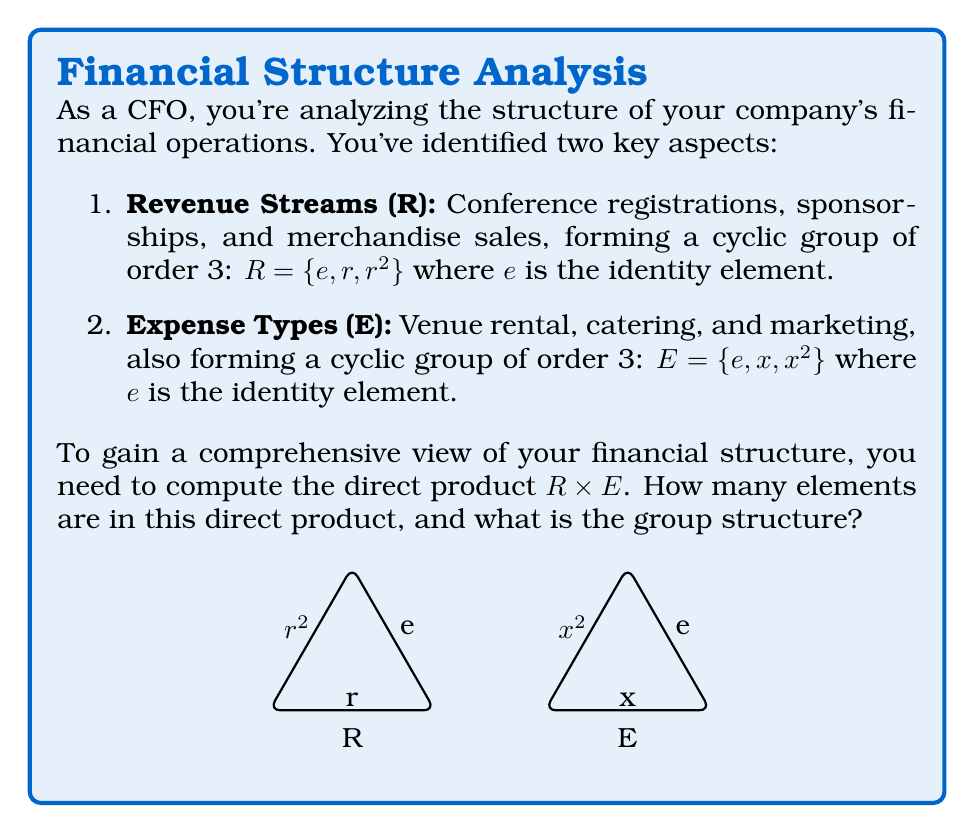Can you answer this question? To solve this problem, we'll follow these steps:

1) First, recall that for two groups $G$ and $H$, the direct product $G \times H$ is defined as the set of all ordered pairs $(g,h)$ where $g \in G$ and $h \in H$. The operation on this product is performed component-wise.

2) In our case, we have:
   $R = \{e, r, r^2\}$ and $E = \{e, x, x^2\}$

3) To form $R \times E$, we need to create all possible pairs:
   $R \times E = \{(e,e), (e,x), (e,x^2), (r,e), (r,x), (r,x^2), (r^2,e), (r^2,x), (r^2,x^2)\}$

4) Count the elements: There are 9 elements in $R \times E$. This is because $|R \times E| = |R| \cdot |E| = 3 \cdot 3 = 9$

5) To determine the group structure, we need to analyze the order of the elements:
   - $(e,e)$ is the identity element, with order 1
   - $(e,x)$ and $(e,x^2)$ have order 3
   - $(r,e)$ and $(r^2,e)$ have order 3
   - $(r,x), (r,x^2), (r^2,x), (r^2,x^2)$ all have order 3

6) The structure of this group is isomorphic to $\mathbb{Z}_3 \times \mathbb{Z}_3$, which is the direct product of two cyclic groups of order 3.
Answer: 9 elements; $\mathbb{Z}_3 \times \mathbb{Z}_3$ 